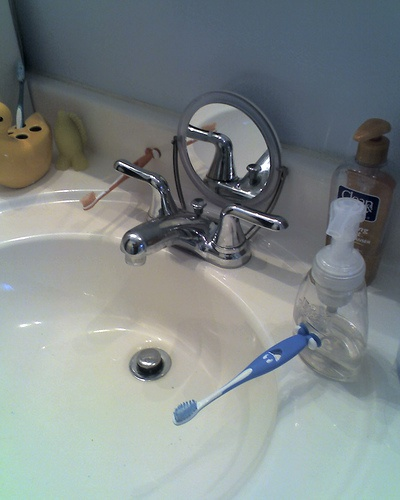Describe the objects in this image and their specific colors. I can see sink in gray, darkgray, lightblue, and lightgray tones, bottle in gray tones, bottle in gray and black tones, toothbrush in gray, blue, and darkgray tones, and toothbrush in gray, black, and blue tones in this image. 